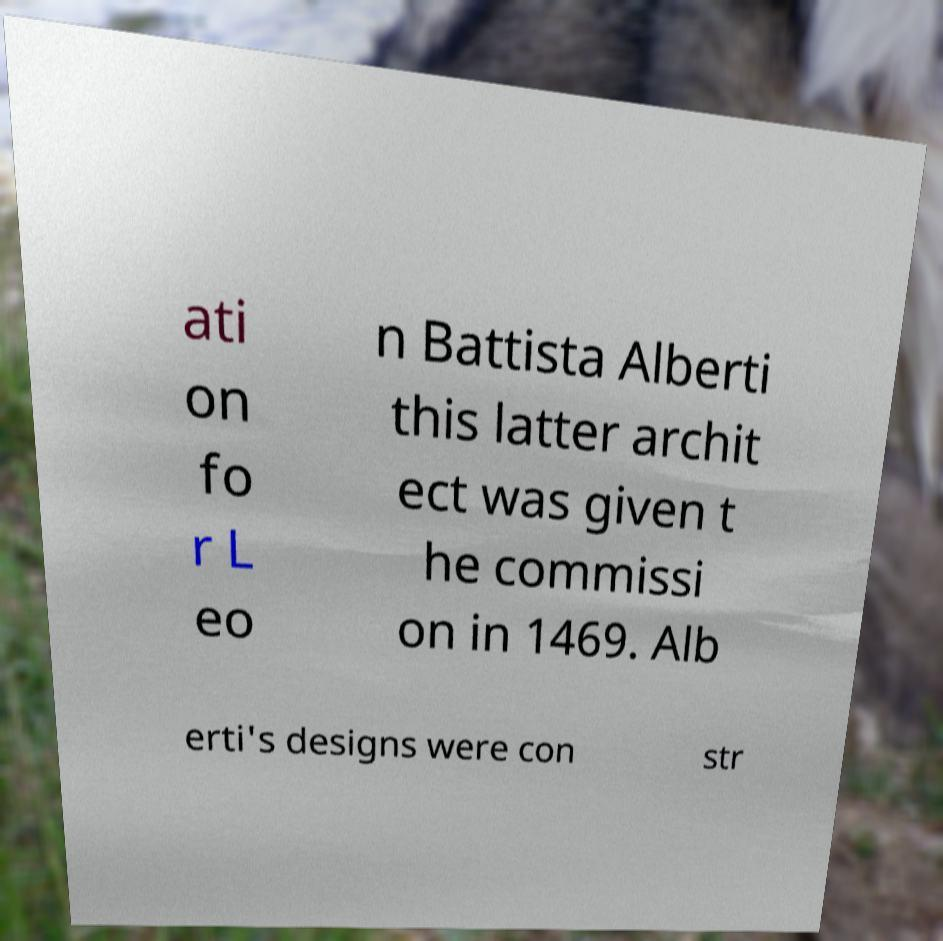Can you accurately transcribe the text from the provided image for me? ati on fo r L eo n Battista Alberti this latter archit ect was given t he commissi on in 1469. Alb erti's designs were con str 